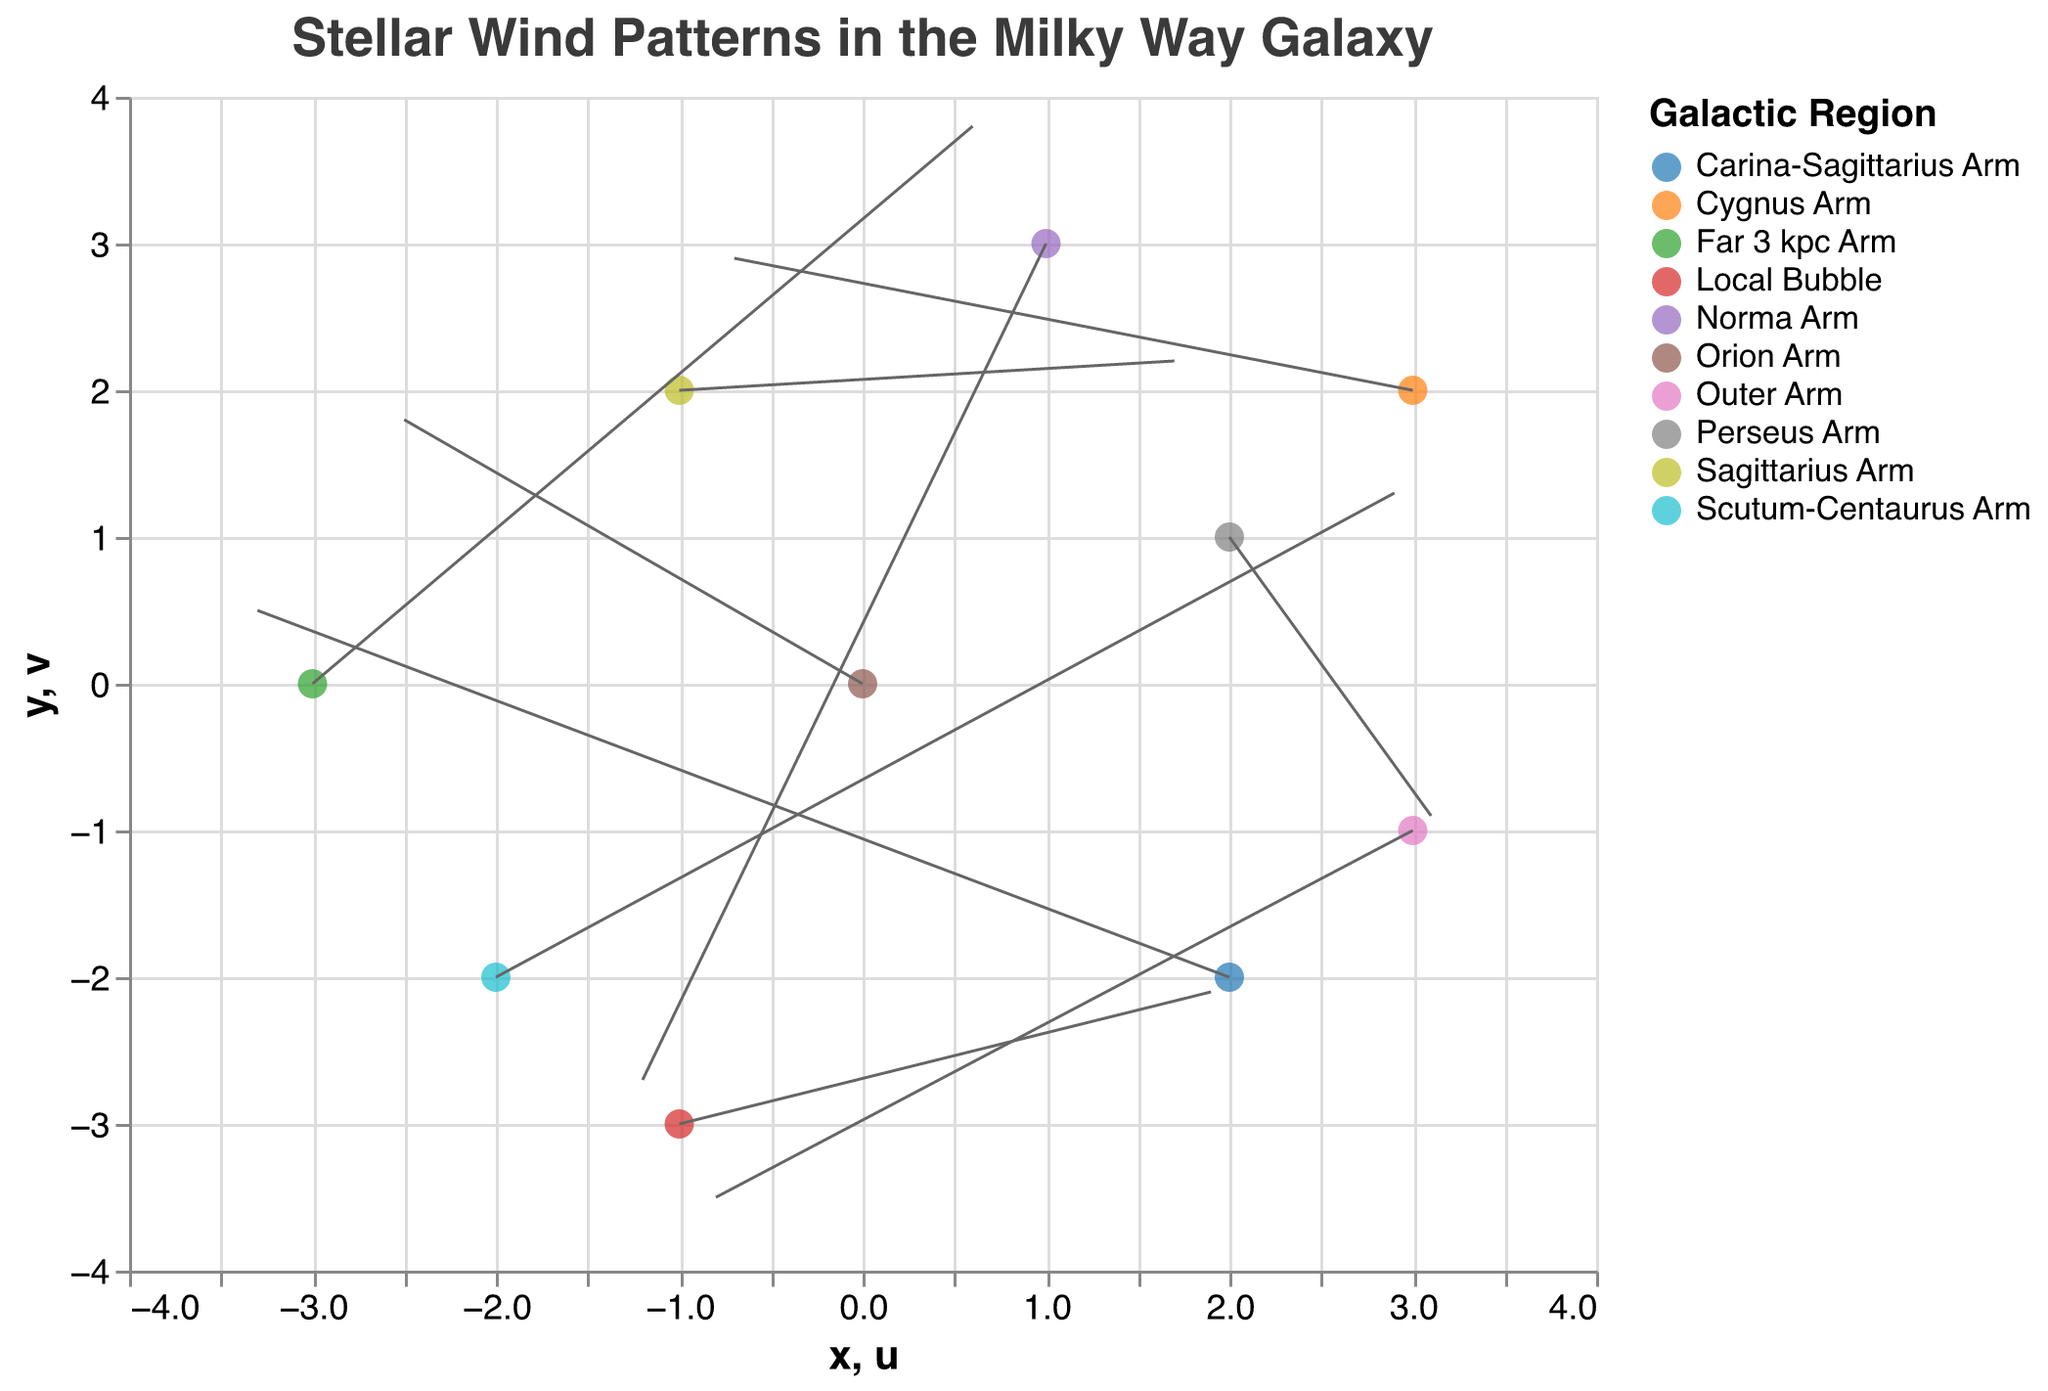what's the title of the figure? The title is displayed at the top of the figure. It provides an overview of what the figure represents.
Answer: Stellar Wind Patterns in the Milky Way Galaxy how many regions are represented in the figure? Each region is represented by a different color in the legend on the right side of the figure. Counting these colors will give the number of regions.
Answer: 10 regions which region has a wind pattern starting at coordinates (1, 3)? The coordinates can be seen in the tooltip when hovering over the points. The region starting at (1, 3) can be identified from there.
Answer: Norma Arm which galactic region shows the strongest wind component in u-direction? The u-component can be identified from the lengths of the arrows along the x-axis. The Perseus Arm shows the longest arrow in the positive u-direction.
Answer: Perseus Arm Compare the wind pattern direction of the Orion Arm and the Outer Arm. Are they similar or opposite? The arrows' directions indicate the wind patterns. The Orion Arm has a direction towards bottom-right, while the Outer Arm has a direction towards top-right, which are opposite directions.
Answer: Opposite Add the x-coordinates of the wind patterns for the Scutum-Centaurus Arm and Far 3 kpc Arm. What's the sum? Identify the x-coordinates from the tooltip for the respective regions and add them: Scutum-Centaurus Arm (-2) + Far 3 kpc Arm (-3).
Answer: -5 which region has the highest positive v-component? The v-component can be identified from the lengths of the arrows along the y-axis. The Far 3 kpc Arm shows the longest arrow in the positive v-direction.
Answer: Far 3 kpc Arm which arm shows a wind pattern going directly upwards? A wind pattern going directly upwards would have a v-component with no horizontal (u) movement. The data shows the Far 3 kpc Arm has an almost directly upwards pattern with a minor u component.
Answer: Far 3 kpc Arm How many regions show wind patterns with a negative v-component? By checking the arrows pointing downwards, we can count the number of regions that exhibit this pattern. These are Orion Arm, Perseus Arm, Norma Arm, Outer Arm, and Local Bubble.
Answer: 5 regions Calculate the average length of the arrows by summing up the magnitudes of the u and v components and dividing by the number of points. First, compute the magnitudes (sqrt(u^2 + v^2)) for each point, sum them up, and divide by the number of points (10). The calculation is complex but follows these steps.
Answer: ~temperature 